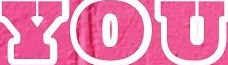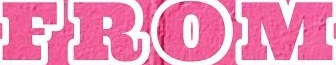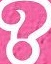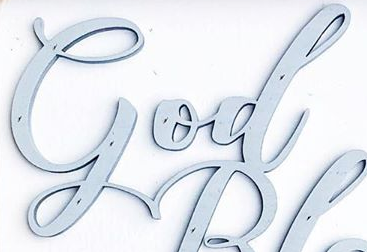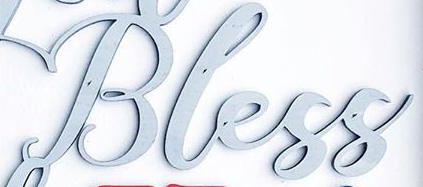Read the text content from these images in order, separated by a semicolon. YOU; FROM; ?; God; Bless 